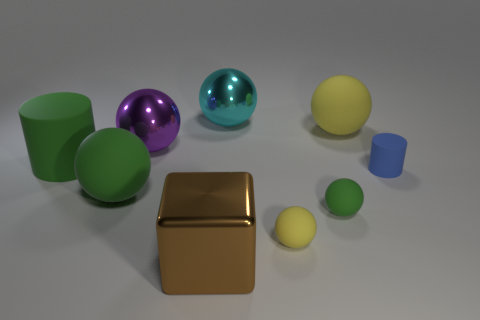What number of things are either big spheres or tiny rubber things that are behind the tiny yellow thing?
Make the answer very short. 6. There is a cylinder right of the green matte sphere left of the purple thing; what color is it?
Offer a very short reply. Blue. How many other objects are the same material as the large yellow object?
Give a very brief answer. 5. How many metallic objects are big green cylinders or cylinders?
Your answer should be compact. 0. There is another shiny thing that is the same shape as the large purple object; what color is it?
Make the answer very short. Cyan. How many objects are yellow metal cylinders or big spheres?
Your answer should be very brief. 4. There is a cyan object that is made of the same material as the large cube; what shape is it?
Provide a short and direct response. Sphere. What number of large things are blue matte things or green metal cylinders?
Offer a terse response. 0. What number of other things are the same color as the cube?
Ensure brevity in your answer.  0. There is a tiny blue object behind the metallic object that is in front of the small green rubber object; how many large spheres are in front of it?
Keep it short and to the point. 1. 